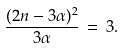<formula> <loc_0><loc_0><loc_500><loc_500>\frac { ( 2 n - 3 \alpha ) ^ { 2 } } { 3 \alpha } \, = \, 3 .</formula> 